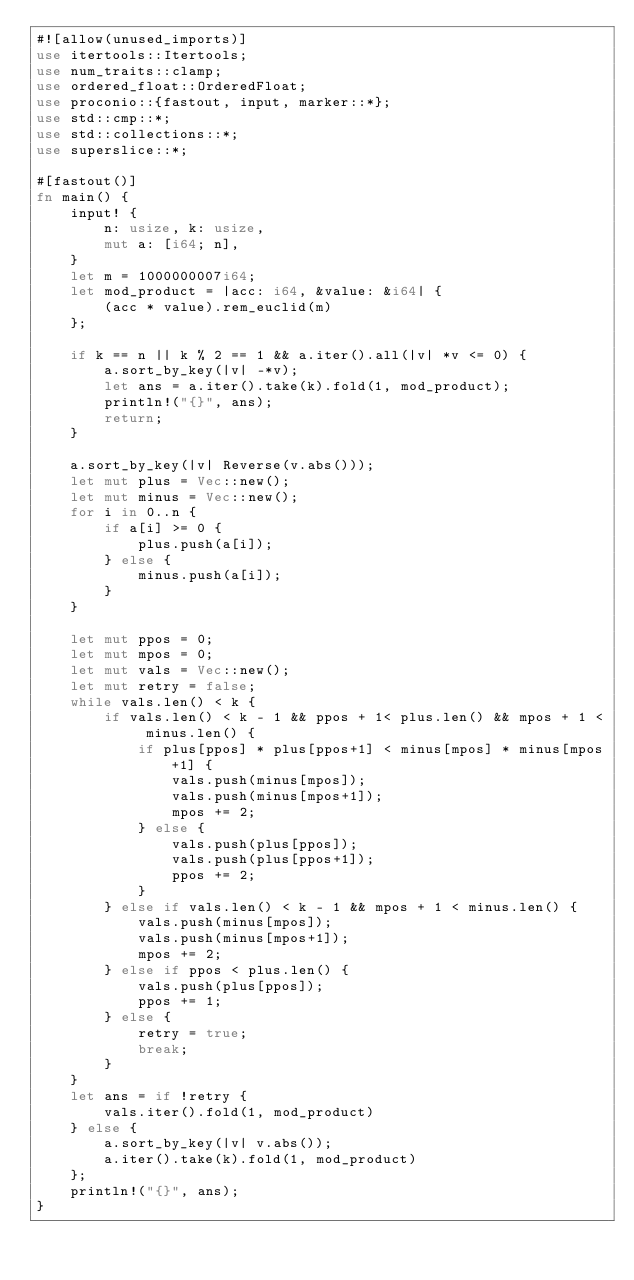<code> <loc_0><loc_0><loc_500><loc_500><_Rust_>#![allow(unused_imports)]
use itertools::Itertools;
use num_traits::clamp;
use ordered_float::OrderedFloat;
use proconio::{fastout, input, marker::*};
use std::cmp::*;
use std::collections::*;
use superslice::*;

#[fastout()]
fn main() {
    input! {
        n: usize, k: usize,
        mut a: [i64; n],
    }
    let m = 1000000007i64;
    let mod_product = |acc: i64, &value: &i64| {
        (acc * value).rem_euclid(m)
    };

    if k == n || k % 2 == 1 && a.iter().all(|v| *v <= 0) {
        a.sort_by_key(|v| -*v);
        let ans = a.iter().take(k).fold(1, mod_product);
        println!("{}", ans);
        return;
    }

    a.sort_by_key(|v| Reverse(v.abs()));
    let mut plus = Vec::new();
    let mut minus = Vec::new();
    for i in 0..n {
        if a[i] >= 0 {
            plus.push(a[i]);
        } else {
            minus.push(a[i]);
        }
    }

    let mut ppos = 0;
    let mut mpos = 0;
    let mut vals = Vec::new();
    let mut retry = false;
    while vals.len() < k {
        if vals.len() < k - 1 && ppos + 1< plus.len() && mpos + 1 < minus.len() {
            if plus[ppos] * plus[ppos+1] < minus[mpos] * minus[mpos+1] {
                vals.push(minus[mpos]);
                vals.push(minus[mpos+1]);
                mpos += 2;
            } else {
                vals.push(plus[ppos]);
                vals.push(plus[ppos+1]);
                ppos += 2;
            }
        } else if vals.len() < k - 1 && mpos + 1 < minus.len() {
            vals.push(minus[mpos]);
            vals.push(minus[mpos+1]);
            mpos += 2;
        } else if ppos < plus.len() {
            vals.push(plus[ppos]);
            ppos += 1;
        } else {
            retry = true;
            break;
        }
    }
    let ans = if !retry {
        vals.iter().fold(1, mod_product)
    } else {
        a.sort_by_key(|v| v.abs());
        a.iter().take(k).fold(1, mod_product)
    };
    println!("{}", ans);
}
</code> 